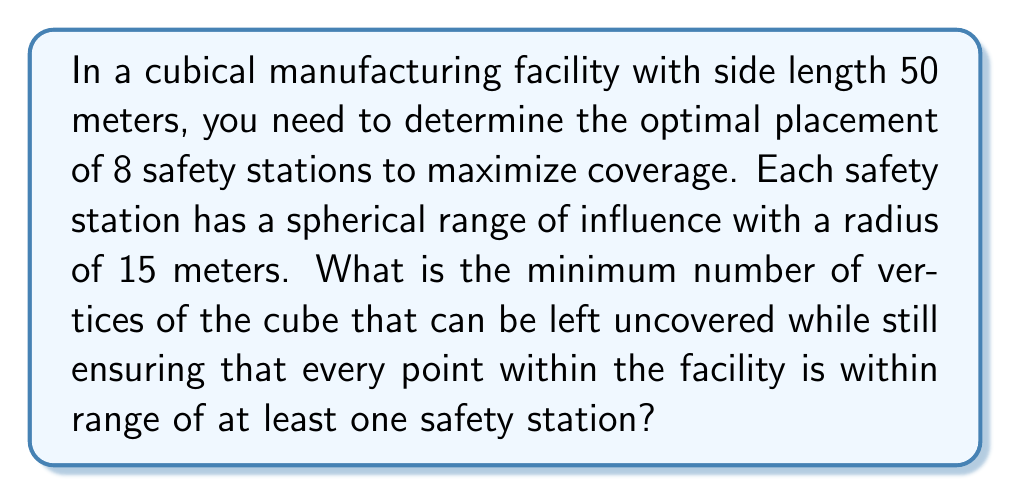Teach me how to tackle this problem. To solve this problem, we need to consider the geometry of the cube and the spheres of influence:

1) First, let's consider the diagonal of the cube:
   $$d = \sqrt{3} \cdot 50 \approx 86.6 \text{ meters}$$

2) The diameter of each sphere of influence is 30 meters. If we place safety stations at opposite corners of the cube, their spheres of influence will not overlap at the center:
   $$86.6 - 30 = 56.6 \text{ meters gap}$$

3) This means we need to place safety stations inside the cube, not just at the vertices.

4) The optimal arrangement is to place the 8 safety stations at the centers of the 8 unit cubes that make up the larger cube when it's divided into 27 equal parts (3x3x3 grid).

5) In this arrangement:
   - The center of each face of the large cube is covered
   - The center of the large cube is covered
   - The midpoints of each edge of the large cube are covered

6) The only points that might not be covered are the vertices of the large cube.

7) To check if a vertex is covered, we need to calculate the distance from a vertex to the nearest safety station:
   $$d = \sqrt{(\frac{50}{3})^2 + (\frac{50}{3})^2 + (\frac{50}{3})^2} \approx 16.67 \text{ meters}$$

8) Since 16.67 > 15, the vertices are not covered by the safety stations.

Therefore, all 8 vertices of the cube can be left uncovered while still ensuring complete coverage of the interior.

[asy]
import three;
size(200);
currentprojection=perspective(6,3,2);
triple[] vertices={
  (0,0,0),(1,0,0),(1,1,0),(0,1,0),
  (0,0,1),(1,0,1),(1,1,1),(0,1,1)
};
triple[] centers={
  (1/3,1/3,1/3),(2/3,1/3,1/3),(1/3,2/3,1/3),(2/3,2/3,1/3),
  (1/3,1/3,2/3),(2/3,1/3,2/3),(1/3,2/3,2/3),(2/3,2/3,2/3)
};
draw(unitcube,blue);
for(triple c : centers) {
  dot(c,red);
}
for(triple v : vertices) {
  dot(v,green);
}
[/asy]
Answer: The minimum number of vertices that can be left uncovered is 8. 